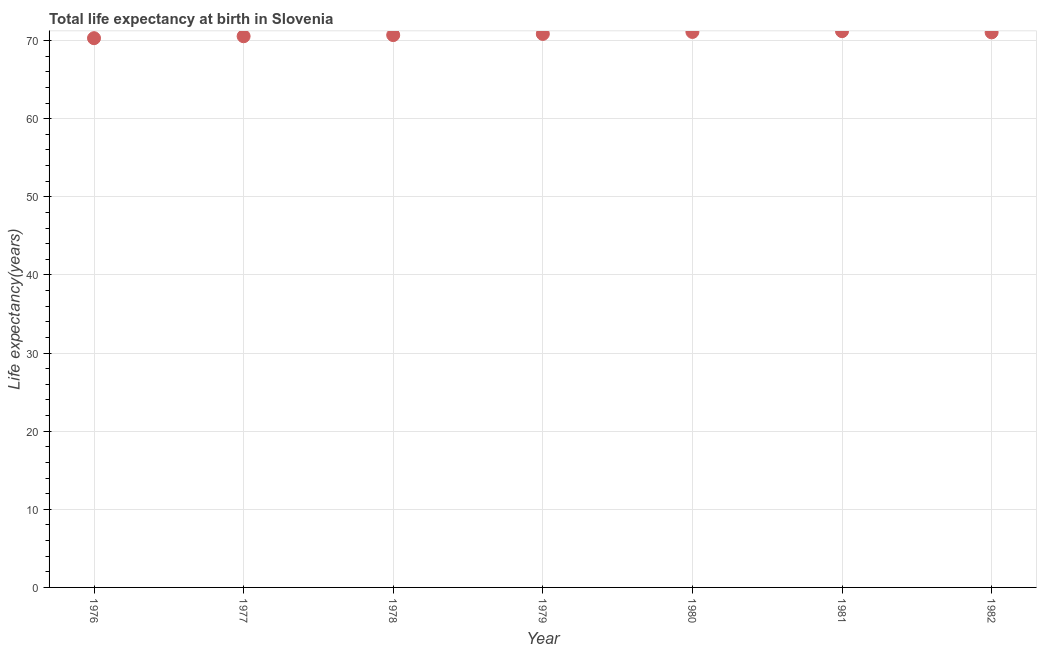What is the life expectancy at birth in 1976?
Provide a succinct answer. 70.31. Across all years, what is the maximum life expectancy at birth?
Your response must be concise. 71.2. Across all years, what is the minimum life expectancy at birth?
Your response must be concise. 70.31. In which year was the life expectancy at birth minimum?
Provide a short and direct response. 1976. What is the sum of the life expectancy at birth?
Make the answer very short. 495.78. What is the difference between the life expectancy at birth in 1979 and 1982?
Give a very brief answer. -0.2. What is the average life expectancy at birth per year?
Provide a short and direct response. 70.83. What is the median life expectancy at birth?
Ensure brevity in your answer.  70.85. In how many years, is the life expectancy at birth greater than 62 years?
Your answer should be very brief. 7. What is the ratio of the life expectancy at birth in 1976 to that in 1978?
Give a very brief answer. 0.99. Is the life expectancy at birth in 1978 less than that in 1980?
Ensure brevity in your answer.  Yes. What is the difference between the highest and the second highest life expectancy at birth?
Ensure brevity in your answer.  0.1. Is the sum of the life expectancy at birth in 1977 and 1979 greater than the maximum life expectancy at birth across all years?
Offer a very short reply. Yes. What is the difference between the highest and the lowest life expectancy at birth?
Provide a short and direct response. 0.9. In how many years, is the life expectancy at birth greater than the average life expectancy at birth taken over all years?
Provide a succinct answer. 4. Does the life expectancy at birth monotonically increase over the years?
Provide a short and direct response. No. How many dotlines are there?
Provide a succinct answer. 1. How many years are there in the graph?
Keep it short and to the point. 7. What is the difference between two consecutive major ticks on the Y-axis?
Offer a very short reply. 10. Are the values on the major ticks of Y-axis written in scientific E-notation?
Make the answer very short. No. What is the title of the graph?
Give a very brief answer. Total life expectancy at birth in Slovenia. What is the label or title of the X-axis?
Your answer should be very brief. Year. What is the label or title of the Y-axis?
Your response must be concise. Life expectancy(years). What is the Life expectancy(years) in 1976?
Provide a short and direct response. 70.31. What is the Life expectancy(years) in 1977?
Ensure brevity in your answer.  70.56. What is the Life expectancy(years) in 1978?
Your answer should be compact. 70.7. What is the Life expectancy(years) in 1979?
Ensure brevity in your answer.  70.85. What is the Life expectancy(years) in 1980?
Keep it short and to the point. 71.1. What is the Life expectancy(years) in 1981?
Keep it short and to the point. 71.2. What is the Life expectancy(years) in 1982?
Your response must be concise. 71.05. What is the difference between the Life expectancy(years) in 1976 and 1977?
Give a very brief answer. -0.25. What is the difference between the Life expectancy(years) in 1976 and 1978?
Offer a very short reply. -0.4. What is the difference between the Life expectancy(years) in 1976 and 1979?
Give a very brief answer. -0.55. What is the difference between the Life expectancy(years) in 1976 and 1980?
Keep it short and to the point. -0.8. What is the difference between the Life expectancy(years) in 1976 and 1981?
Offer a very short reply. -0.9. What is the difference between the Life expectancy(years) in 1976 and 1982?
Offer a terse response. -0.75. What is the difference between the Life expectancy(years) in 1977 and 1978?
Your answer should be compact. -0.15. What is the difference between the Life expectancy(years) in 1977 and 1979?
Keep it short and to the point. -0.3. What is the difference between the Life expectancy(years) in 1977 and 1980?
Your response must be concise. -0.55. What is the difference between the Life expectancy(years) in 1977 and 1981?
Offer a terse response. -0.65. What is the difference between the Life expectancy(years) in 1977 and 1982?
Give a very brief answer. -0.5. What is the difference between the Life expectancy(years) in 1978 and 1979?
Your answer should be compact. -0.15. What is the difference between the Life expectancy(years) in 1978 and 1980?
Your answer should be compact. -0.4. What is the difference between the Life expectancy(years) in 1978 and 1981?
Provide a short and direct response. -0.5. What is the difference between the Life expectancy(years) in 1978 and 1982?
Make the answer very short. -0.35. What is the difference between the Life expectancy(years) in 1979 and 1980?
Provide a succinct answer. -0.25. What is the difference between the Life expectancy(years) in 1979 and 1981?
Your response must be concise. -0.35. What is the difference between the Life expectancy(years) in 1980 and 1981?
Give a very brief answer. -0.1. What is the difference between the Life expectancy(years) in 1980 and 1982?
Your response must be concise. 0.05. What is the difference between the Life expectancy(years) in 1981 and 1982?
Keep it short and to the point. 0.15. What is the ratio of the Life expectancy(years) in 1976 to that in 1978?
Provide a succinct answer. 0.99. What is the ratio of the Life expectancy(years) in 1976 to that in 1979?
Keep it short and to the point. 0.99. What is the ratio of the Life expectancy(years) in 1976 to that in 1980?
Offer a terse response. 0.99. What is the ratio of the Life expectancy(years) in 1976 to that in 1981?
Ensure brevity in your answer.  0.99. What is the ratio of the Life expectancy(years) in 1976 to that in 1982?
Ensure brevity in your answer.  0.99. What is the ratio of the Life expectancy(years) in 1977 to that in 1978?
Your response must be concise. 1. What is the ratio of the Life expectancy(years) in 1977 to that in 1979?
Provide a short and direct response. 1. What is the ratio of the Life expectancy(years) in 1977 to that in 1982?
Offer a terse response. 0.99. What is the ratio of the Life expectancy(years) in 1978 to that in 1981?
Offer a very short reply. 0.99. What is the ratio of the Life expectancy(years) in 1979 to that in 1981?
Make the answer very short. 0.99. What is the ratio of the Life expectancy(years) in 1979 to that in 1982?
Give a very brief answer. 1. 